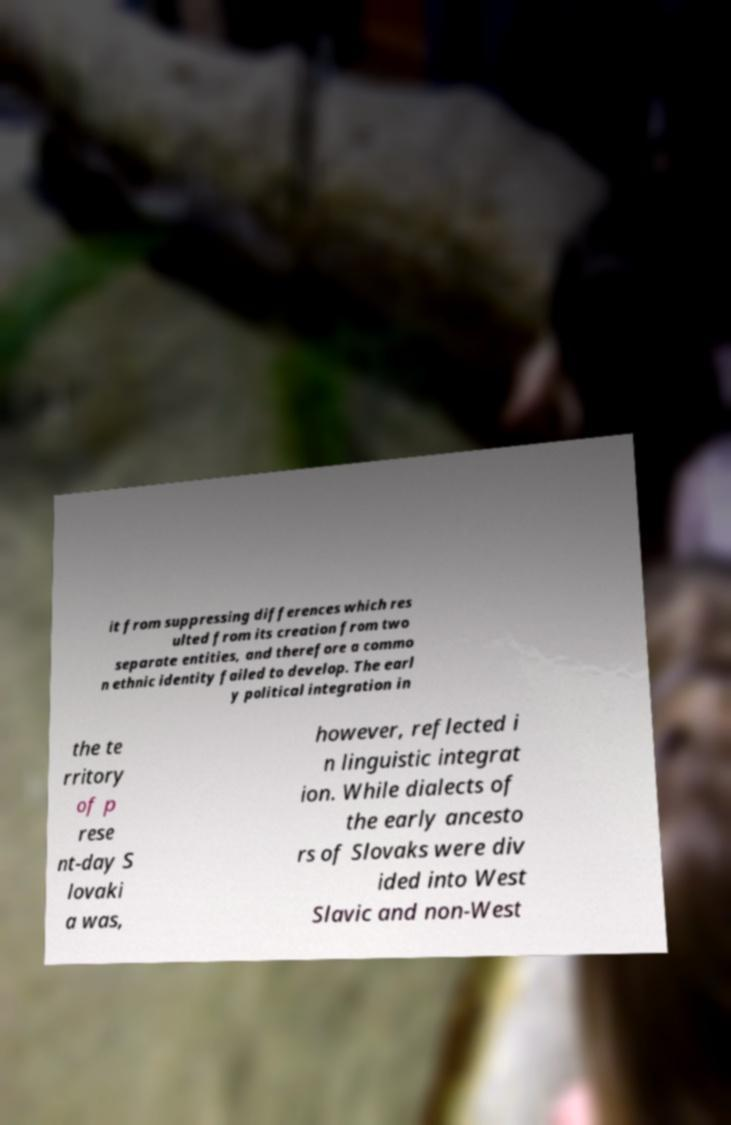What messages or text are displayed in this image? I need them in a readable, typed format. it from suppressing differences which res ulted from its creation from two separate entities, and therefore a commo n ethnic identity failed to develop. The earl y political integration in the te rritory of p rese nt-day S lovaki a was, however, reflected i n linguistic integrat ion. While dialects of the early ancesto rs of Slovaks were div ided into West Slavic and non-West 